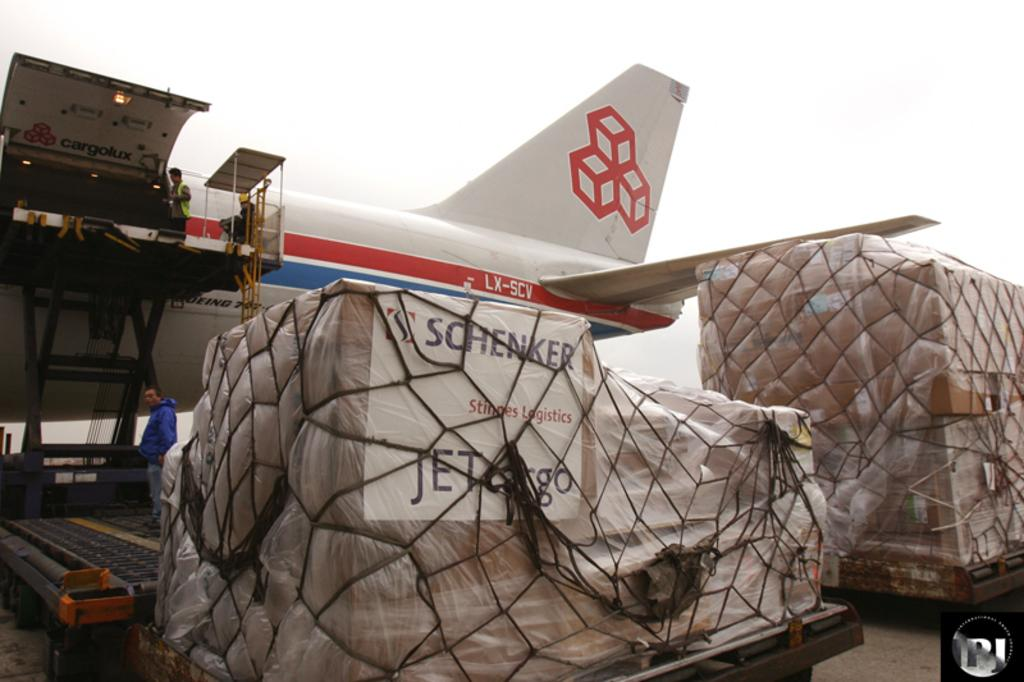<image>
Relay a brief, clear account of the picture shown. A Schenker Jet cargo plane is being unloaded by a crew. 